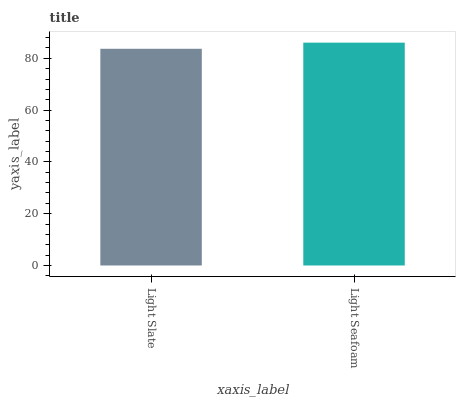Is Light Slate the minimum?
Answer yes or no. Yes. Is Light Seafoam the maximum?
Answer yes or no. Yes. Is Light Seafoam the minimum?
Answer yes or no. No. Is Light Seafoam greater than Light Slate?
Answer yes or no. Yes. Is Light Slate less than Light Seafoam?
Answer yes or no. Yes. Is Light Slate greater than Light Seafoam?
Answer yes or no. No. Is Light Seafoam less than Light Slate?
Answer yes or no. No. Is Light Seafoam the high median?
Answer yes or no. Yes. Is Light Slate the low median?
Answer yes or no. Yes. Is Light Slate the high median?
Answer yes or no. No. Is Light Seafoam the low median?
Answer yes or no. No. 